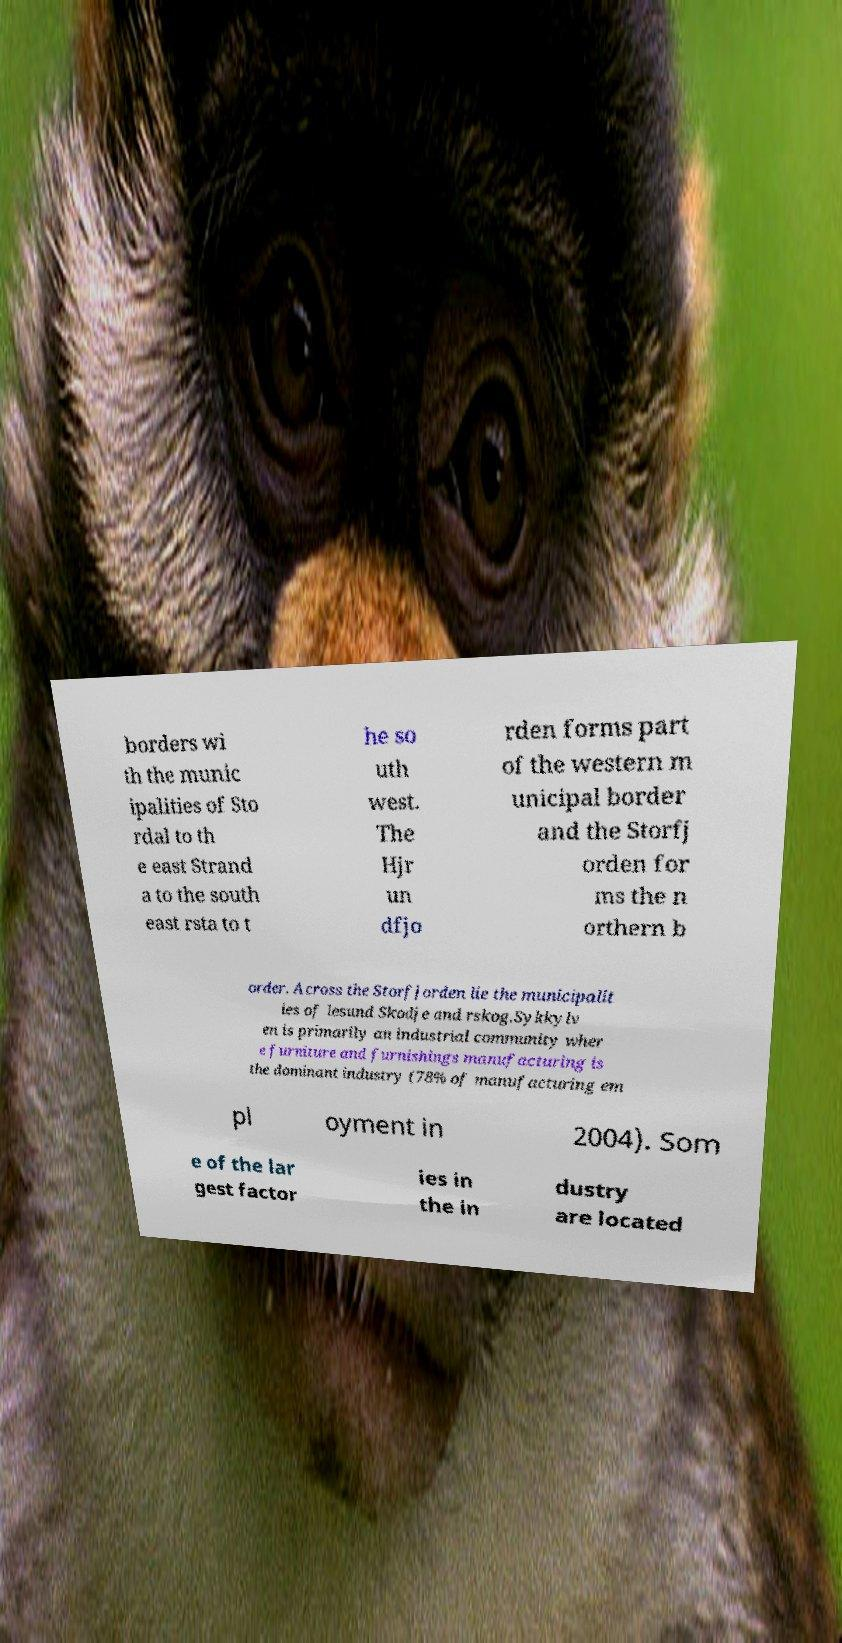There's text embedded in this image that I need extracted. Can you transcribe it verbatim? borders wi th the munic ipalities of Sto rdal to th e east Strand a to the south east rsta to t he so uth west. The Hjr un dfjo rden forms part of the western m unicipal border and the Storfj orden for ms the n orthern b order. Across the Storfjorden lie the municipalit ies of lesund Skodje and rskog.Sykkylv en is primarily an industrial community wher e furniture and furnishings manufacturing is the dominant industry (78% of manufacturing em pl oyment in 2004). Som e of the lar gest factor ies in the in dustry are located 